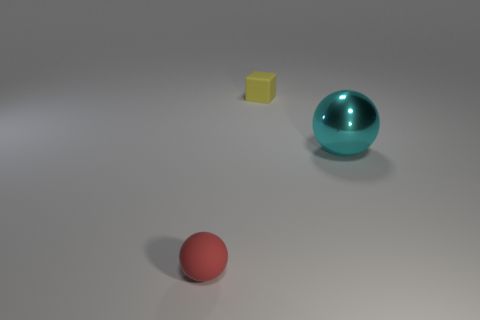Add 1 red matte objects. How many objects exist? 4 Subtract all spheres. How many objects are left? 1 Subtract 0 blue blocks. How many objects are left? 3 Subtract all balls. Subtract all yellow cubes. How many objects are left? 0 Add 2 tiny yellow rubber blocks. How many tiny yellow rubber blocks are left? 3 Add 2 small red things. How many small red things exist? 3 